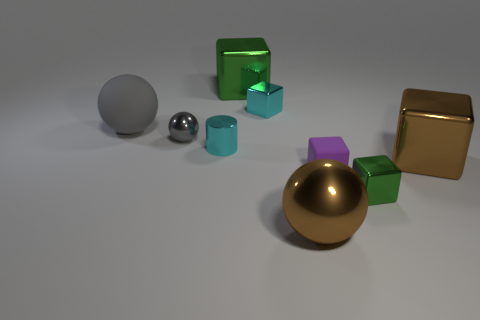What can you infer about the lighting and shadows in the scene? The lighting in the scene seems to be coming from the upper left, as deduced from the shadows cast on the right side of the objects. The shadows are fairly soft, suggesting the light source is not too harsh, and there's diffused illumination contributing to the gentle shading. The direction and nature of the shadows add depth and dimensionality to the arrangement. 